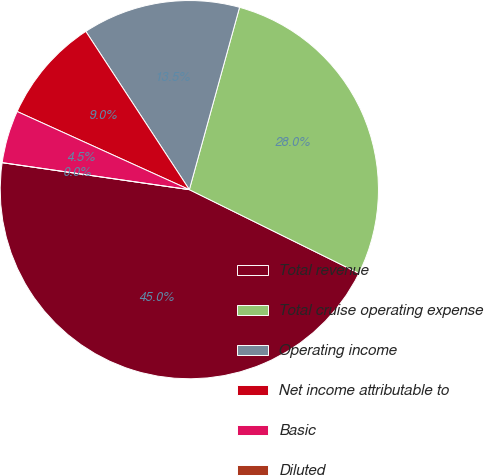Convert chart to OTSL. <chart><loc_0><loc_0><loc_500><loc_500><pie_chart><fcel>Total revenue<fcel>Total cruise operating expense<fcel>Operating income<fcel>Net income attributable to<fcel>Basic<fcel>Diluted<nl><fcel>44.99%<fcel>28.02%<fcel>13.5%<fcel>9.0%<fcel>4.5%<fcel>0.0%<nl></chart> 